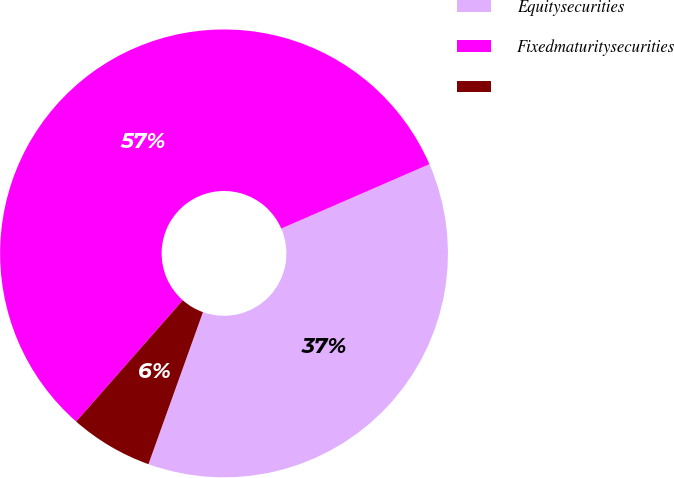Convert chart to OTSL. <chart><loc_0><loc_0><loc_500><loc_500><pie_chart><fcel>Equitysecurities<fcel>Fixedmaturitysecurities<fcel>Unnamed: 2<nl><fcel>37.0%<fcel>57.0%<fcel>6.0%<nl></chart> 